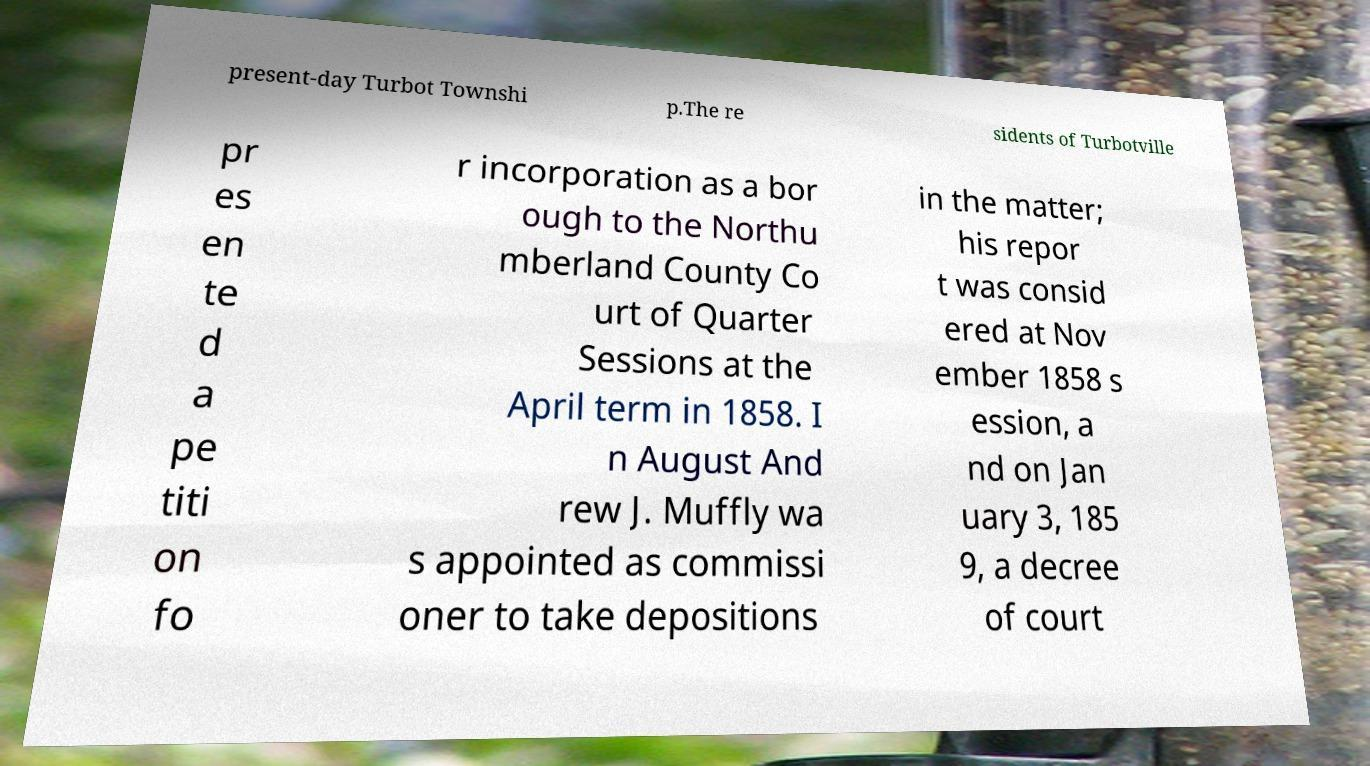For documentation purposes, I need the text within this image transcribed. Could you provide that? present-day Turbot Townshi p.The re sidents of Turbotville pr es en te d a pe titi on fo r incorporation as a bor ough to the Northu mberland County Co urt of Quarter Sessions at the April term in 1858. I n August And rew J. Muffly wa s appointed as commissi oner to take depositions in the matter; his repor t was consid ered at Nov ember 1858 s ession, a nd on Jan uary 3, 185 9, a decree of court 